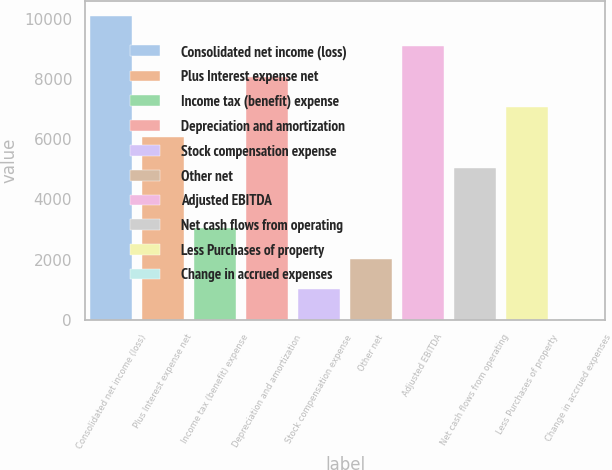Convert chart. <chart><loc_0><loc_0><loc_500><loc_500><bar_chart><fcel>Consolidated net income (loss)<fcel>Plus Interest expense net<fcel>Income tax (benefit) expense<fcel>Depreciation and amortization<fcel>Stock compensation expense<fcel>Other net<fcel>Adjusted EBITDA<fcel>Net cash flows from operating<fcel>Less Purchases of property<fcel>Change in accrued expenses<nl><fcel>10101<fcel>6064.6<fcel>3037.3<fcel>8082.8<fcel>1019.1<fcel>2028.2<fcel>9091.9<fcel>5055.5<fcel>7073.7<fcel>10<nl></chart> 